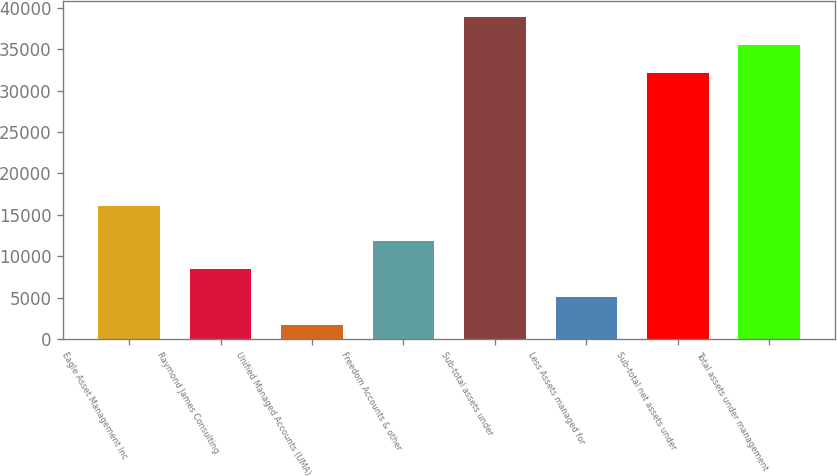<chart> <loc_0><loc_0><loc_500><loc_500><bar_chart><fcel>Eagle Asset Management Inc<fcel>Raymond James Consulting<fcel>Unified Managed Accounts (UMA)<fcel>Freedom Accounts & other<fcel>Sub-total assets under<fcel>Less Assets managed for<fcel>Sub-total net assets under<fcel>Total assets under management<nl><fcel>16092<fcel>8471.2<fcel>1677<fcel>11868.3<fcel>38863.2<fcel>5074.1<fcel>32069<fcel>35466.1<nl></chart> 